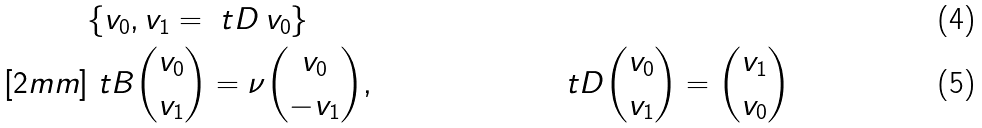Convert formula to latex. <formula><loc_0><loc_0><loc_500><loc_500>& \{ v _ { 0 } , v _ { 1 } = \ t D \, v _ { 0 } \} & & \\ [ 2 m m ] & \ t B \binom { v _ { 0 } } { v _ { 1 } } = \nu \binom { v _ { 0 } } { - v _ { 1 } } , & & \ t D \binom { v _ { 0 } } { v _ { 1 } } = \binom { v _ { 1 } } { v _ { 0 } }</formula> 